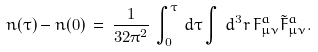<formula> <loc_0><loc_0><loc_500><loc_500>n ( \tau ) - n ( 0 ) \, = \, \frac { 1 } { 3 2 \pi ^ { 2 } } \, \int _ { 0 } ^ { \tau } \, d \tau \int \, d ^ { 3 } r \, F ^ { a } _ { \mu \nu } \tilde { F } ^ { a } _ { \mu \nu } .</formula> 